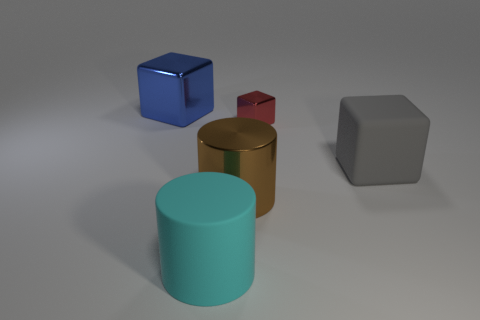There is a metal cube to the right of the blue metal object; is it the same size as the rubber cylinder?
Keep it short and to the point. No. Is the number of large brown metallic cylinders that are behind the big blue metallic block less than the number of gray metallic cylinders?
Give a very brief answer. No. How many objects are cyan rubber objects or blocks that are left of the matte block?
Offer a terse response. 3. The cylinder that is the same material as the large blue thing is what color?
Offer a terse response. Brown. What number of things are either big gray objects or small metal objects?
Your answer should be compact. 2. There is another shiny thing that is the same size as the blue thing; what color is it?
Provide a short and direct response. Brown. How many objects are big shiny things that are to the right of the big matte cylinder or tiny metal things?
Your answer should be compact. 2. How many other objects are there of the same size as the gray rubber cube?
Provide a succinct answer. 3. What is the size of the matte thing on the right side of the red cube?
Keep it short and to the point. Large. What shape is the big brown object that is made of the same material as the tiny thing?
Offer a terse response. Cylinder. 